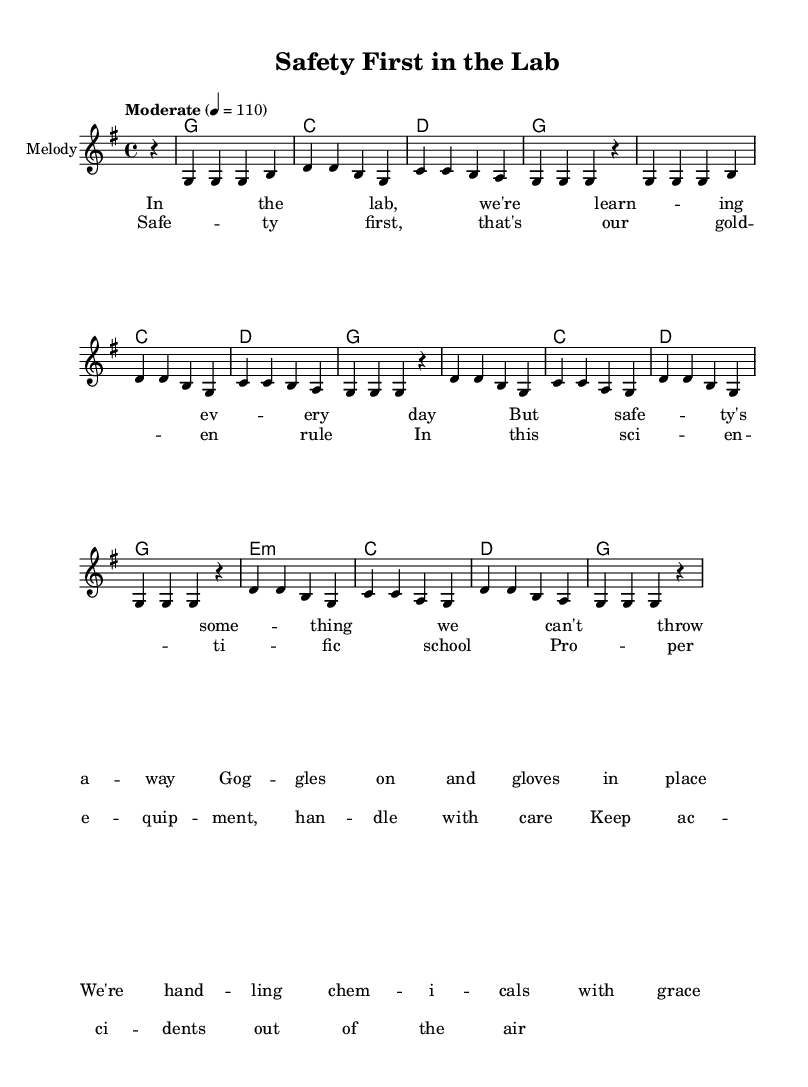What is the key signature of this music? The key signature indicated in the global section shows one sharp, which corresponds to the key of G major.
Answer: G major What is the time signature of this music? The time signature is found in the global section, which is written as 4/4. This indicates there are four beats in each measure and the quarter note receives one beat.
Answer: 4/4 What is the tempo marking for this piece? The tempo is specified as "Moderate" with a speed of 110 beats per minute indicated in the global section.
Answer: Moderate 4 = 110 How many measures are dedicated to the verse section? By counting the groups of notes and bars in the melody section labeled as "Verse," we find there are 8 measures dedicated to it.
Answer: 8 measures What is the primary theme of the lyrics? Analyzing the lyrics presented, the primary theme revolves around lab safety and the importance of handling equipment properly. This is evident in lines discussing goggles, gloves, and safe practices.
Answer: Lab safety How many chords are used in the chorus? By examining the chord progression written under the chorus section, four unique chords (g, c, d, and e minor) are used throughout.
Answer: Four chords What safety item is mentioned in the lyrics? The lyrics specifically mention "goggles" as an essential item for safety while handling chemicals in the lab.
Answer: Goggles 